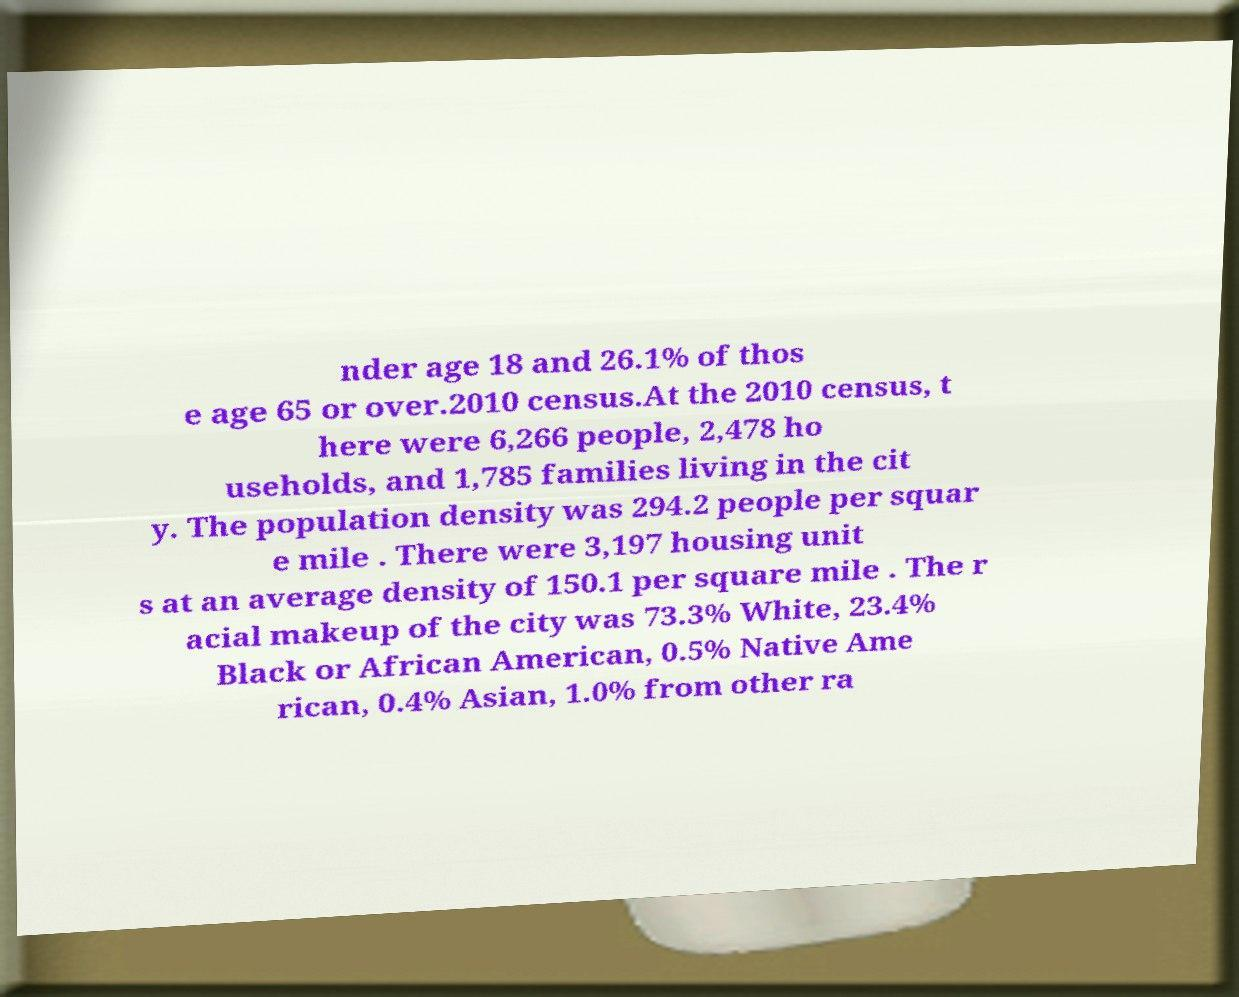There's text embedded in this image that I need extracted. Can you transcribe it verbatim? nder age 18 and 26.1% of thos e age 65 or over.2010 census.At the 2010 census, t here were 6,266 people, 2,478 ho useholds, and 1,785 families living in the cit y. The population density was 294.2 people per squar e mile . There were 3,197 housing unit s at an average density of 150.1 per square mile . The r acial makeup of the city was 73.3% White, 23.4% Black or African American, 0.5% Native Ame rican, 0.4% Asian, 1.0% from other ra 